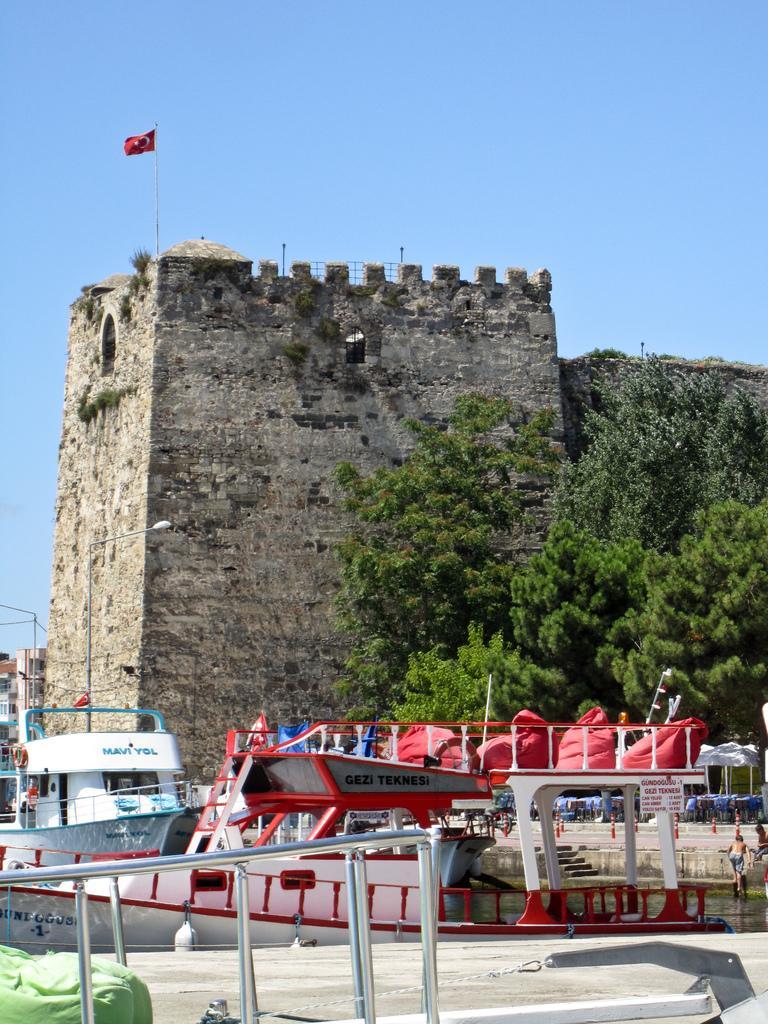Please provide a concise description of this image. In this image, we can see fort, trees, boats, stairs, water, walkway, rods, few people, flags, buildings, pole with light. Background there is a sky. 